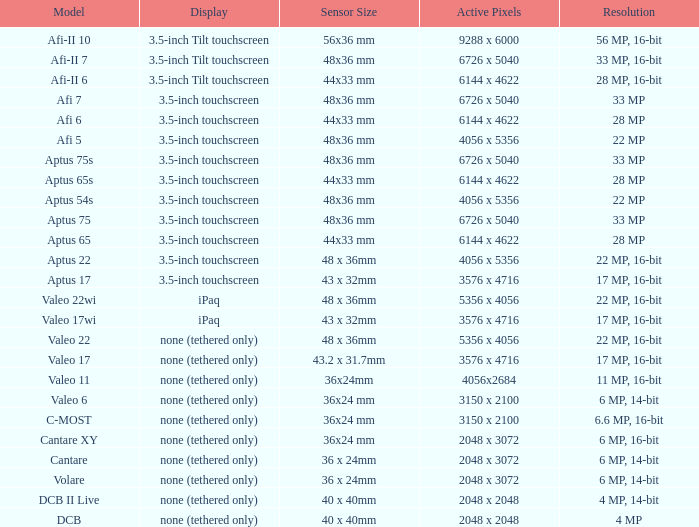Which model has a sensor sized 48x36 mm, pixels of 6726 x 5040, and a 33 mp resolution? Afi 7, Aptus 75s, Aptus 75. 